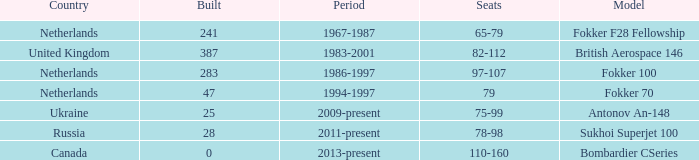Between which years were there 241 fokker 70 model cabins built? 1994-1997. 